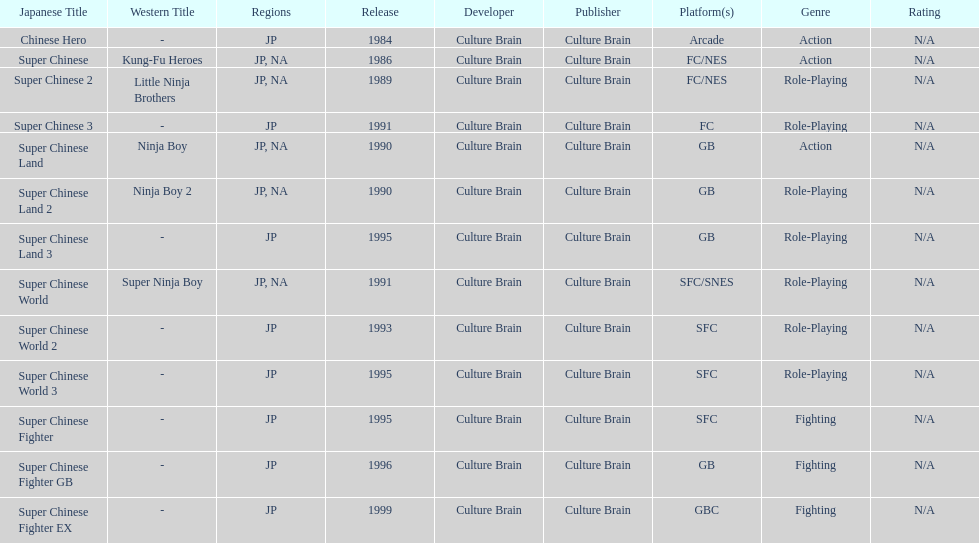Of the titles released in north america, which had the least releases? Super Chinese World. 